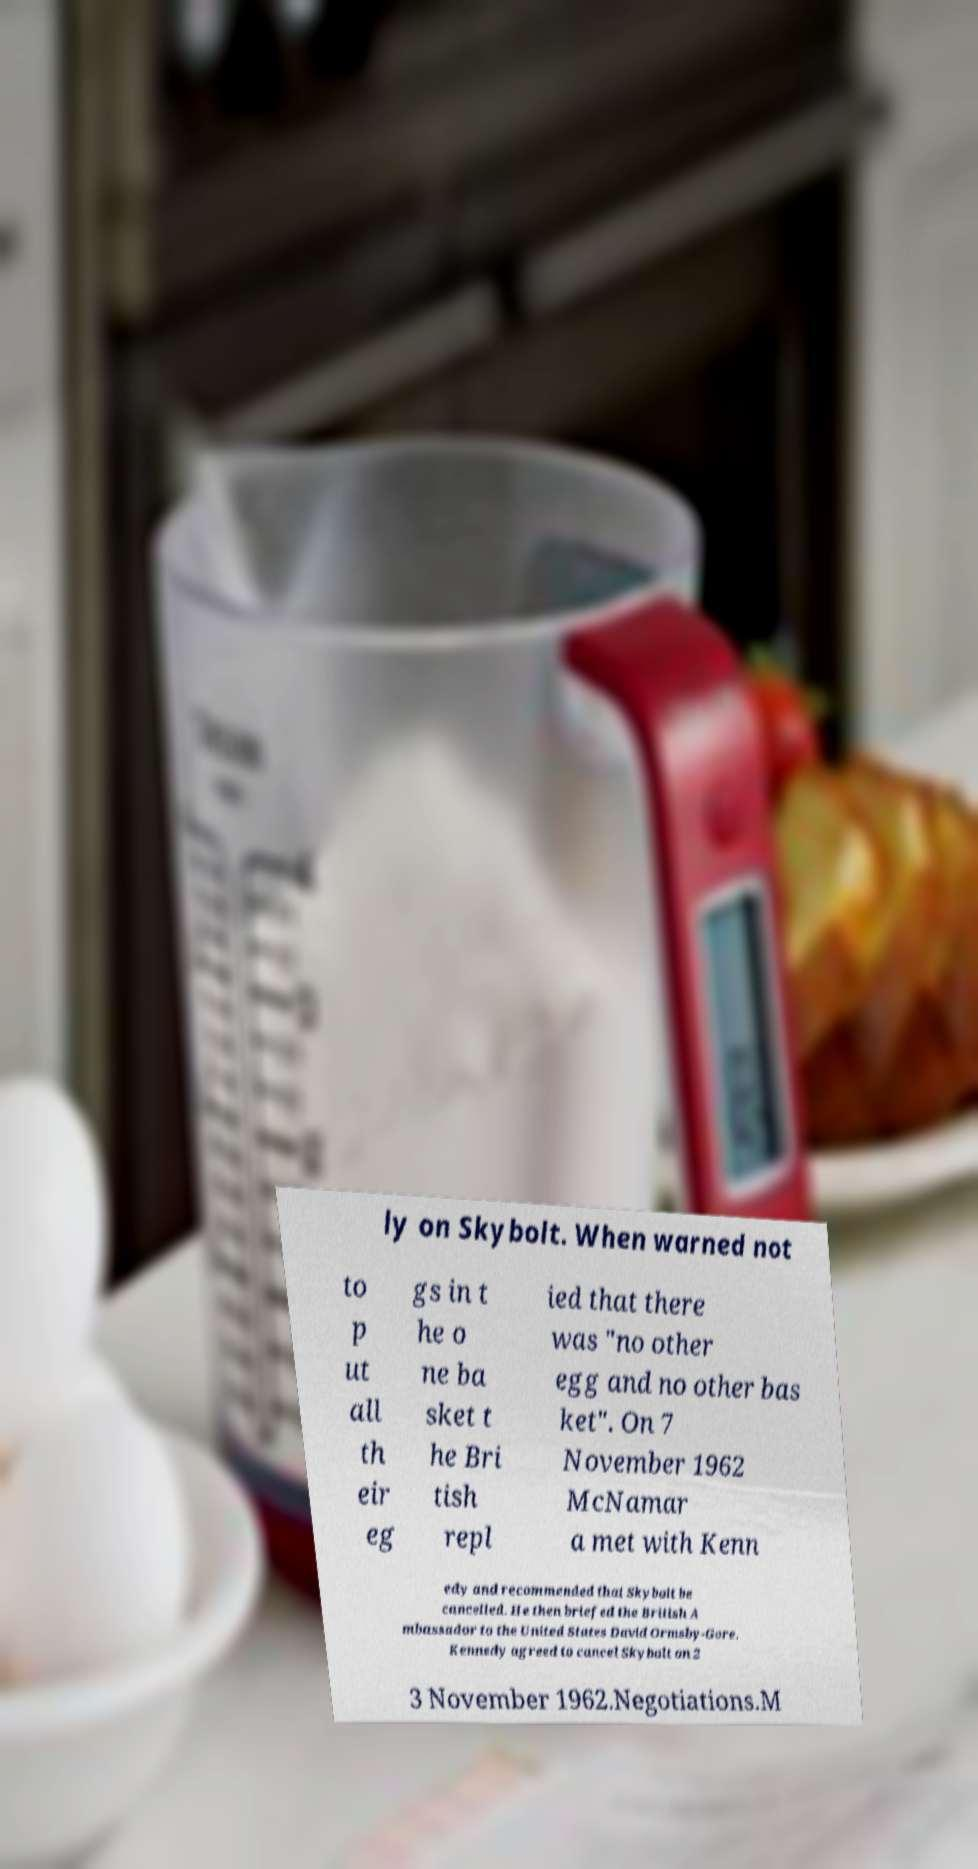For documentation purposes, I need the text within this image transcribed. Could you provide that? ly on Skybolt. When warned not to p ut all th eir eg gs in t he o ne ba sket t he Bri tish repl ied that there was "no other egg and no other bas ket". On 7 November 1962 McNamar a met with Kenn edy and recommended that Skybolt be cancelled. He then briefed the British A mbassador to the United States David Ormsby-Gore. Kennedy agreed to cancel Skybolt on 2 3 November 1962.Negotiations.M 